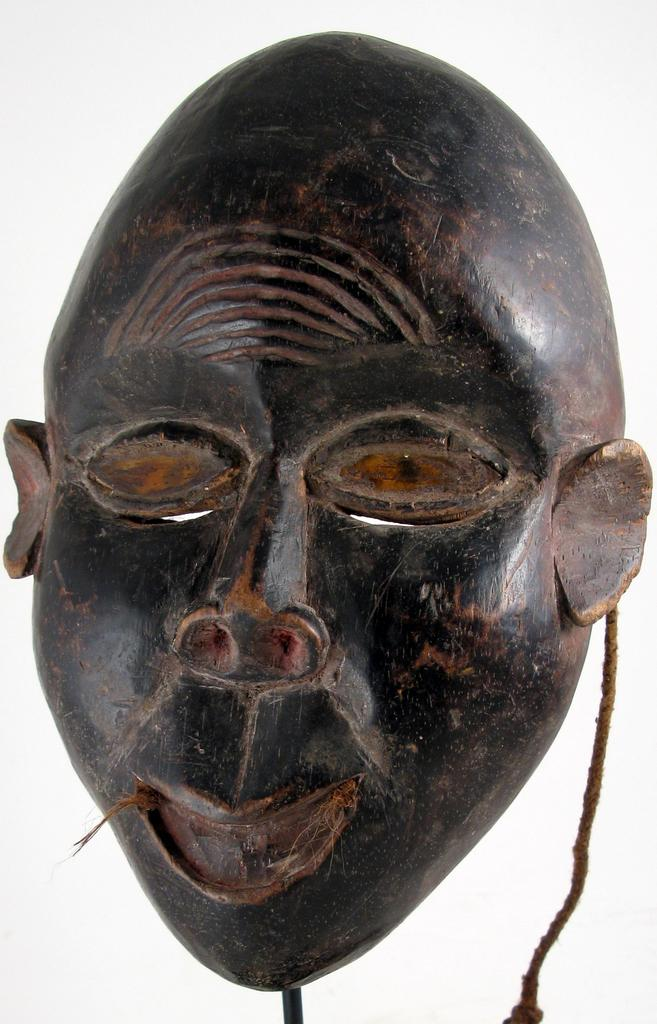What object is present in the image? There is a mask in the image. What color is the background of the image? The background of the image is white. What type of nail is being used to hang the mask in the image? There is no nail present in the image, nor is the mask being hung. What type of voice can be heard coming from the mask in the image? There is no sound or voice coming from the mask in the image. What type of knowledge is being shared by the mask in the image? The mask in the image is an object and does not share any knowledge. 